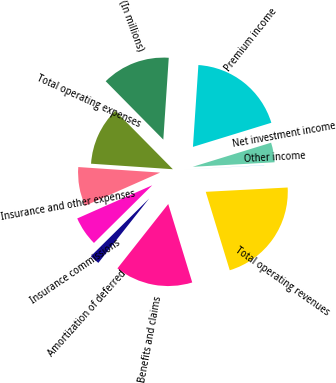Convert chart to OTSL. <chart><loc_0><loc_0><loc_500><loc_500><pie_chart><fcel>(In millions)<fcel>Premium income<fcel>Net investment income<fcel>Other income<fcel>Total operating revenues<fcel>Benefits and claims<fcel>Amortization of deferred<fcel>Insurance commissions<fcel>Insurance and other expenses<fcel>Total operating expenses<nl><fcel>13.45%<fcel>19.19%<fcel>3.87%<fcel>0.04%<fcel>21.11%<fcel>15.36%<fcel>1.95%<fcel>5.79%<fcel>7.7%<fcel>11.53%<nl></chart> 